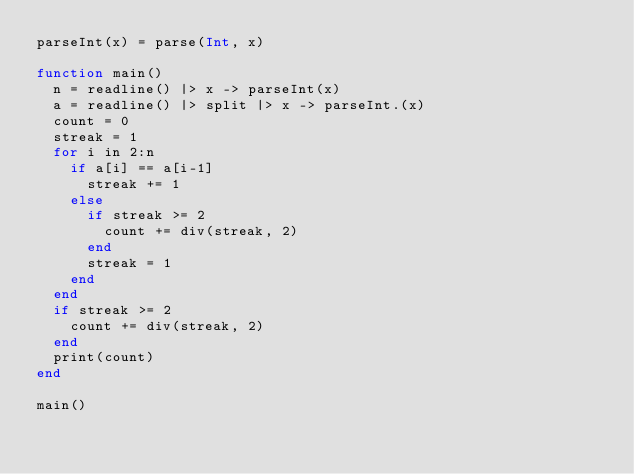<code> <loc_0><loc_0><loc_500><loc_500><_Julia_>parseInt(x) = parse(Int, x)

function main()
	n = readline() |> x -> parseInt(x)
	a = readline() |> split |> x -> parseInt.(x)
	count = 0
	streak = 1
	for i in 2:n
		if a[i] == a[i-1]
			streak += 1
		else
			if streak >= 2
				count += div(streak, 2)
			end
			streak = 1
		end
	end
	if streak >= 2
		count += div(streak, 2)
	end
	print(count)
end

main()</code> 